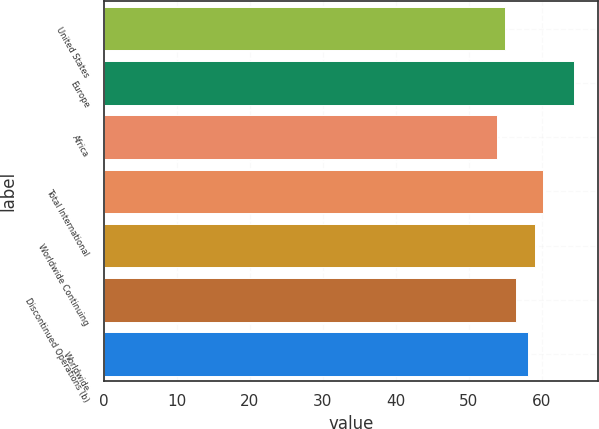<chart> <loc_0><loc_0><loc_500><loc_500><bar_chart><fcel>United States<fcel>Europe<fcel>Africa<fcel>Total International<fcel>Worldwide Continuing<fcel>Discontinued Operations (b)<fcel>Worldwide<nl><fcel>54.96<fcel>64.46<fcel>53.91<fcel>60.17<fcel>59.12<fcel>56.47<fcel>58.06<nl></chart> 